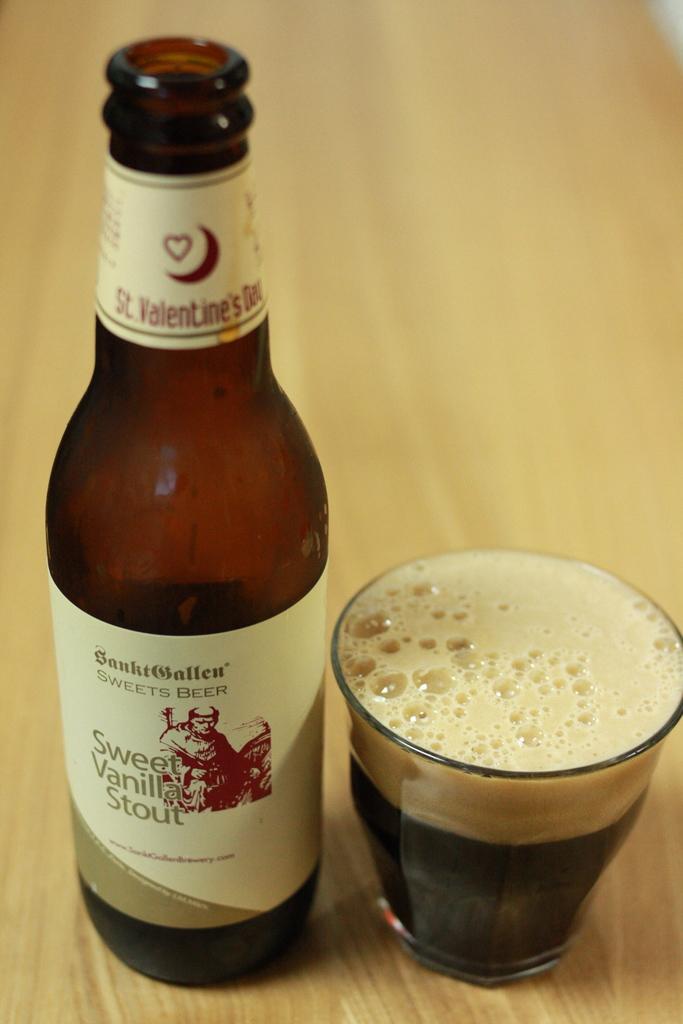What type of beer is this?
Make the answer very short. Sweet vanilla stout. This is a sweet vanilla what?
Your response must be concise. Stout. 